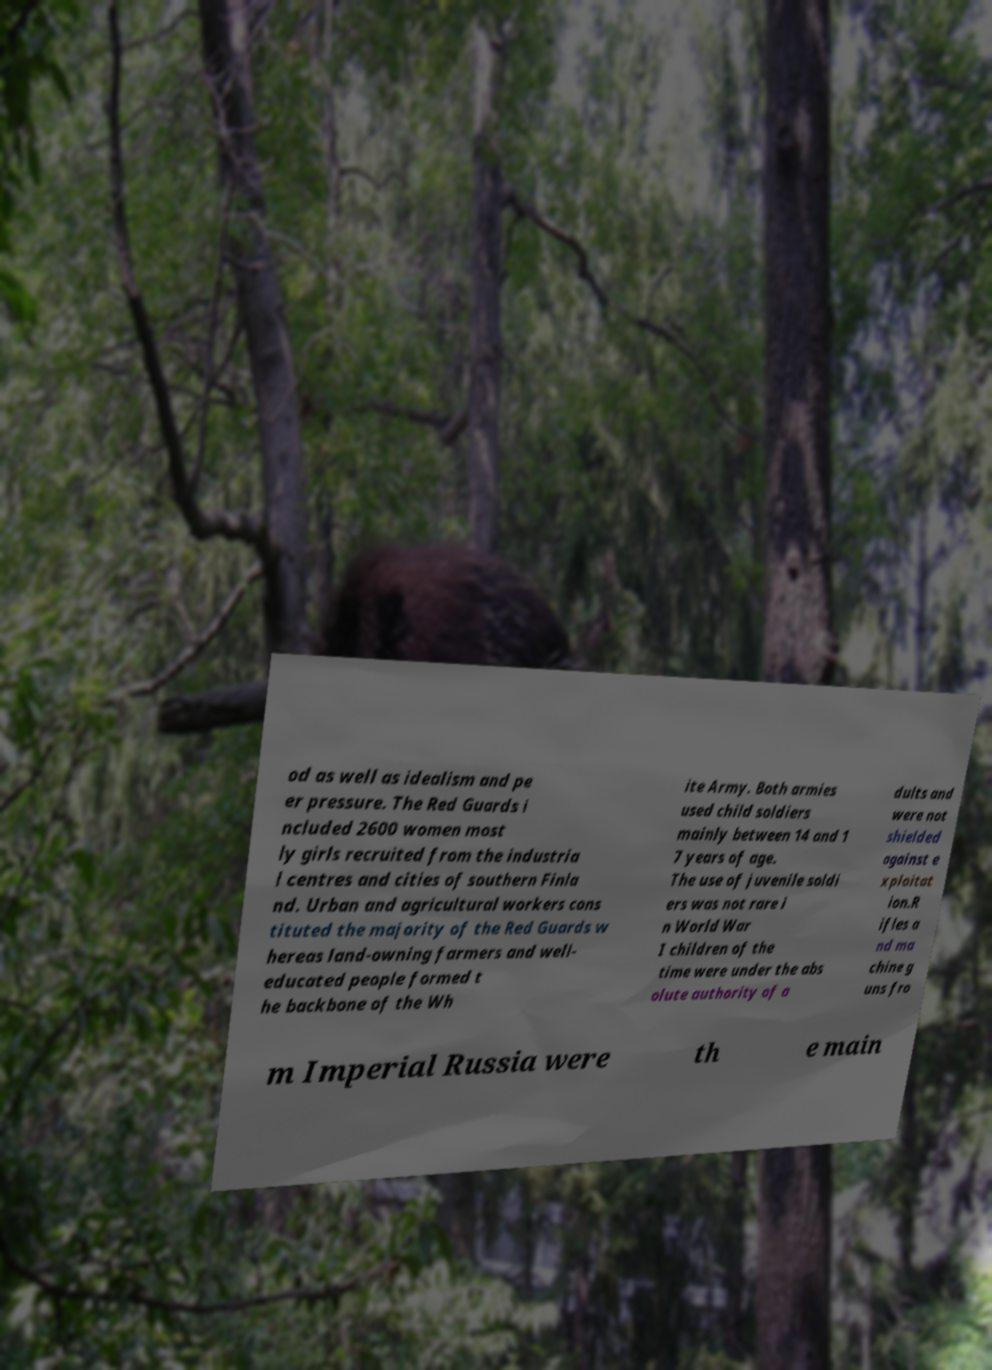Can you read and provide the text displayed in the image?This photo seems to have some interesting text. Can you extract and type it out for me? od as well as idealism and pe er pressure. The Red Guards i ncluded 2600 women most ly girls recruited from the industria l centres and cities of southern Finla nd. Urban and agricultural workers cons tituted the majority of the Red Guards w hereas land-owning farmers and well- educated people formed t he backbone of the Wh ite Army. Both armies used child soldiers mainly between 14 and 1 7 years of age. The use of juvenile soldi ers was not rare i n World War I children of the time were under the abs olute authority of a dults and were not shielded against e xploitat ion.R ifles a nd ma chine g uns fro m Imperial Russia were th e main 